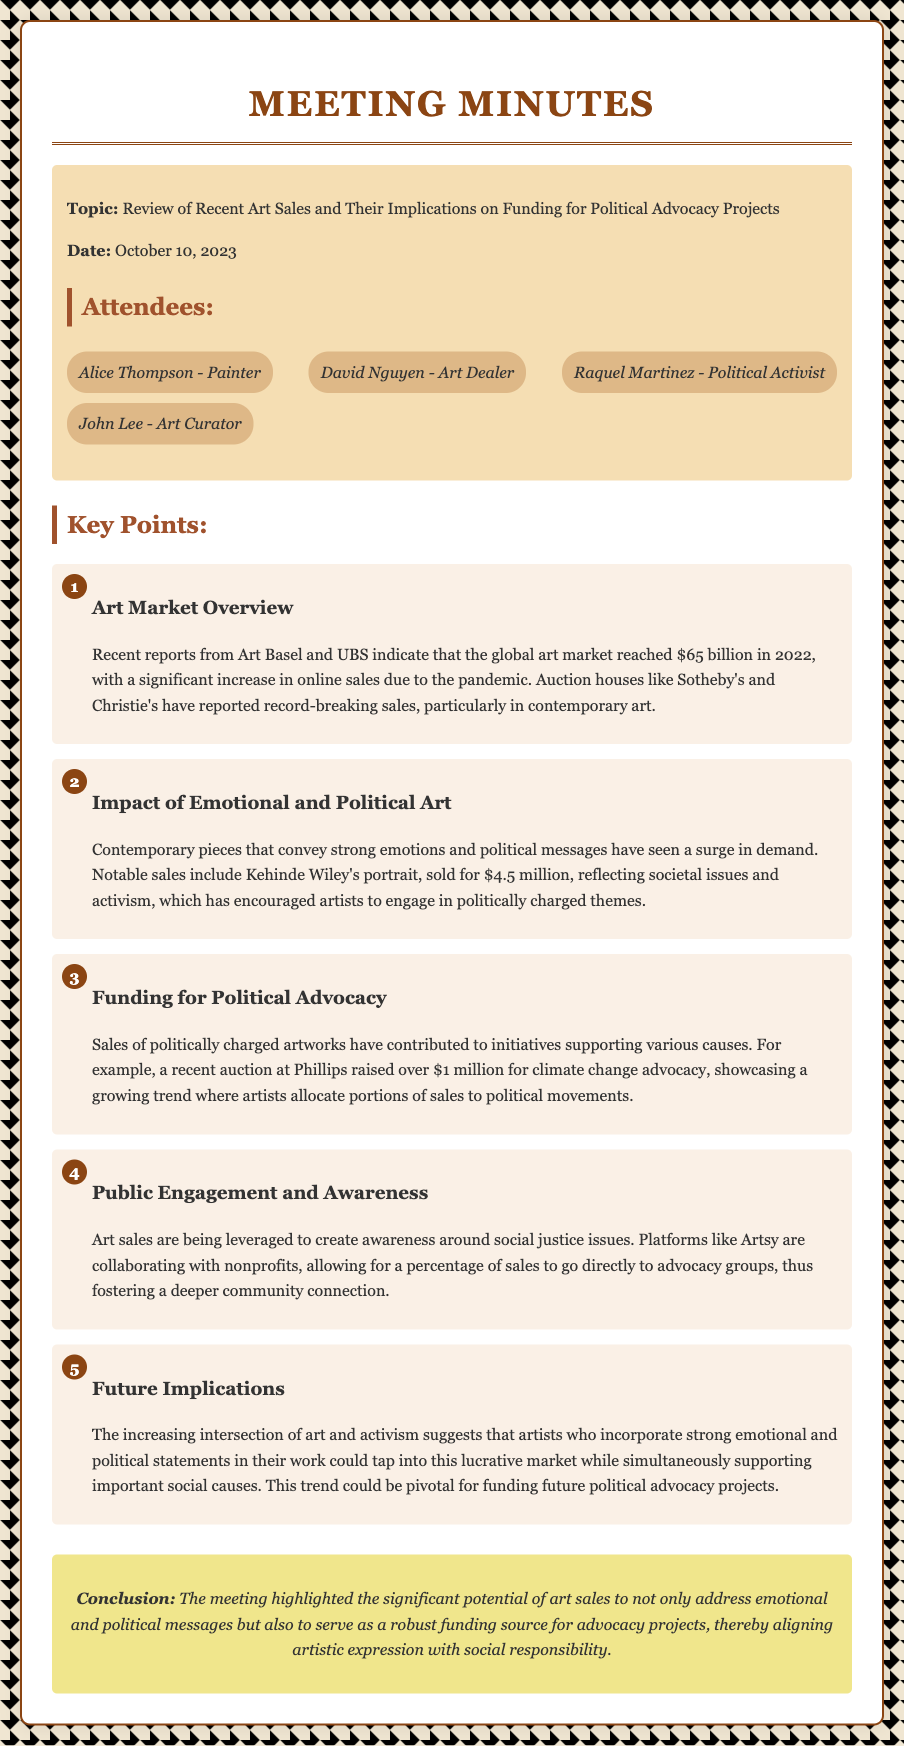What was the date of the meeting? The date of the meeting is explicitly mentioned in the introduction of the document.
Answer: October 10, 2023 Who is the painter listed as an attendee? The document lists attendees, and Alice Thompson is identified as a painter.
Answer: Alice Thompson What was the revenue of the global art market in 2022? The document states the revenue from a report about the global art market in 2022.
Answer: $65 billion Which artist's portrait was sold for $4.5 million? The document includes a specific mention of notable sales, including the artist and sale amount.
Answer: Kehinde Wiley How much was raised for climate change advocacy at a recent auction? The document details the amount raised from sales specifically aimed at political causes, including climate change.
Answer: over $1 million What is the main focus of the discussion in the meeting? The main topic is presented at the start and throughout the document.
Answer: Art sales and political advocacy What significant trend does the meeting highlight regarding artists? The document emphasizes a particular trend in the art market with political engagement by artists.
Answer: Political engagement What platform is mentioned as collaborating with nonprofits? The document indicates a specific platform that works with nonprofits to support advocacy.
Answer: Artsy What is the overall conclusion of the meeting? The conclusion at the end summarizes the main outcomes discussed during the meeting.
Answer: Art sales address emotional and political messages while funding advocacy projects 